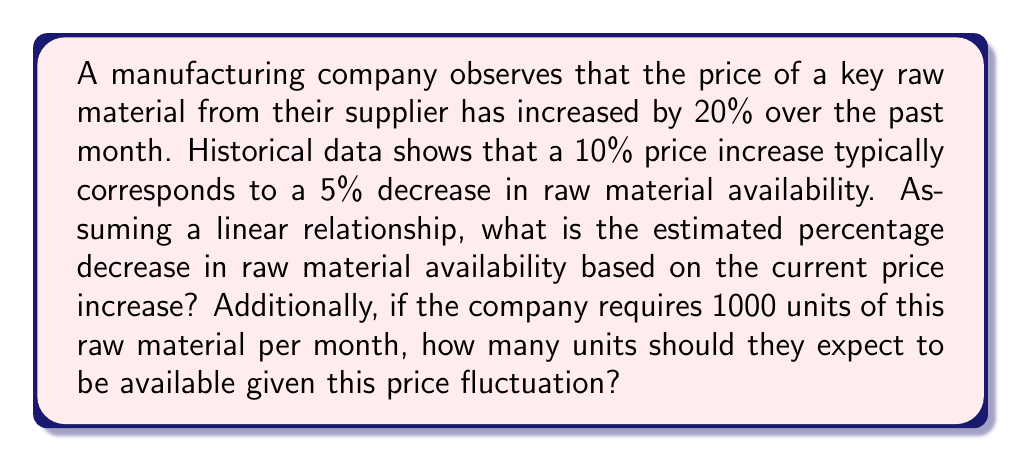Solve this math problem. Let's approach this problem step-by-step:

1) First, we need to establish the relationship between price increase and availability decrease:
   10% price increase → 5% availability decrease

2) We can express this as a ratio:
   $\frac{\text{Availability Decrease}}{\text{Price Increase}} = \frac{5\%}{10\%} = 0.5$

3) Now, we have a 20% price increase. Assuming a linear relationship, we can set up the following equation:
   $\frac{x}{20\%} = 0.5$, where $x$ is the percentage decrease in availability

4) Solving for $x$:
   $x = 20\% \times 0.5 = 10\%$

5) Therefore, the estimated decrease in raw material availability is 10%.

6) For the second part of the question, we need to calculate the available units:
   - The company normally requires 1000 units
   - Availability has decreased by 10%
   - Available units = $1000 \times (1 - 0.10) = 1000 \times 0.90 = 900$ units
Answer: 10% decrease in availability; 900 units available 